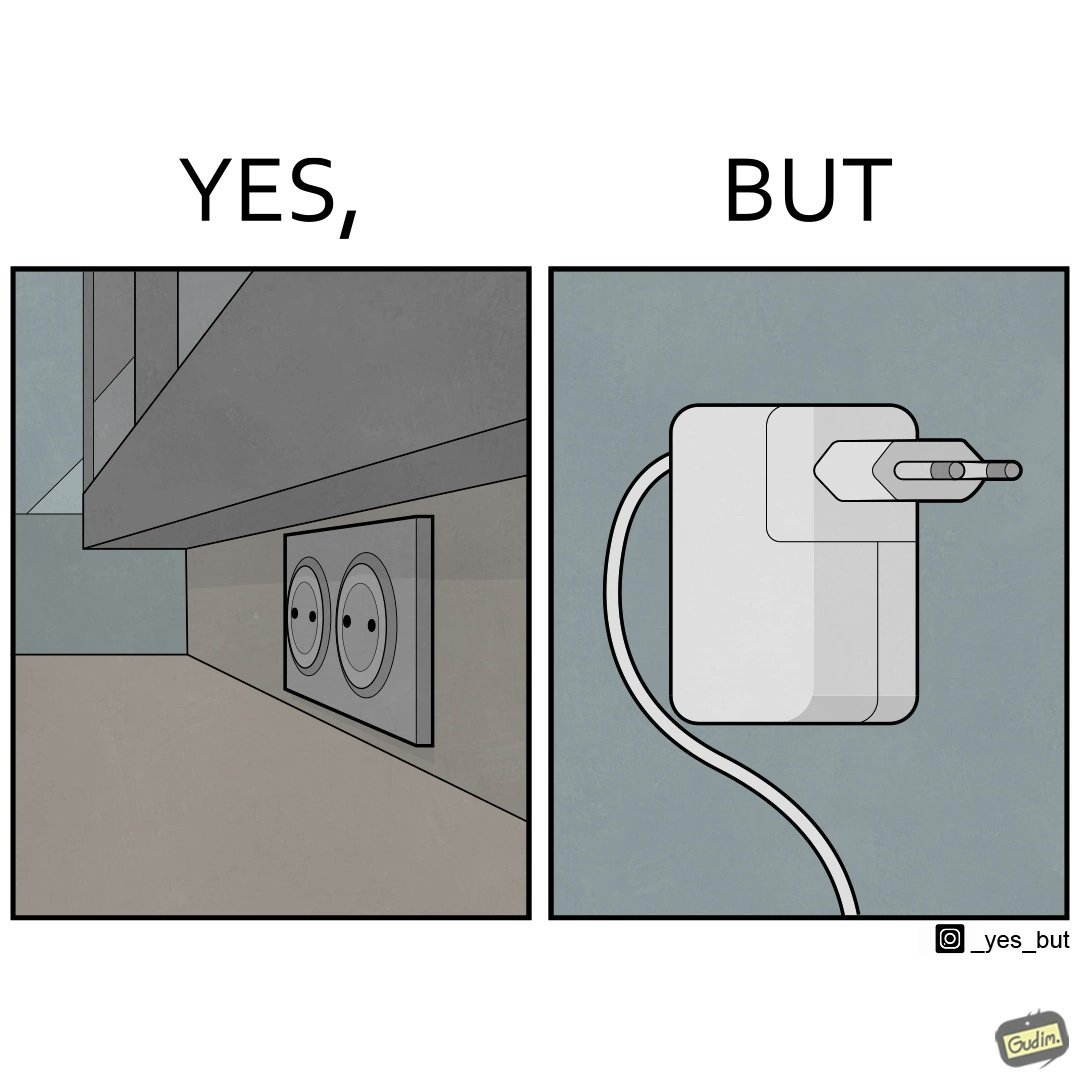Describe the satirical element in this image. The image is funny, as there are two electrical sockets side-by-side, but the adapter is shaped in such a way, that if two adapters are inserted into the two sockets, they will butt into each other, leading to inconvenience. 